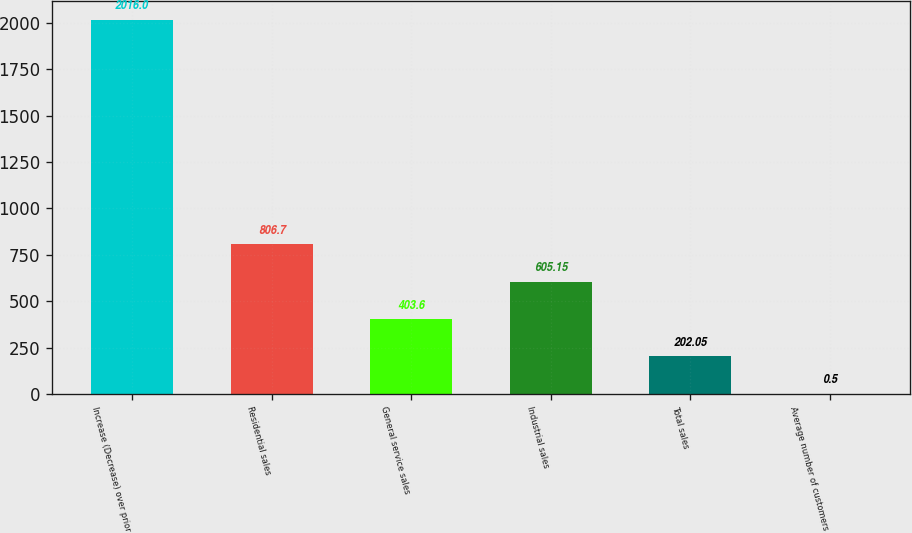Convert chart. <chart><loc_0><loc_0><loc_500><loc_500><bar_chart><fcel>Increase (Decrease) over prior<fcel>Residential sales<fcel>General service sales<fcel>Industrial sales<fcel>Total sales<fcel>Average number of customers<nl><fcel>2016<fcel>806.7<fcel>403.6<fcel>605.15<fcel>202.05<fcel>0.5<nl></chart> 